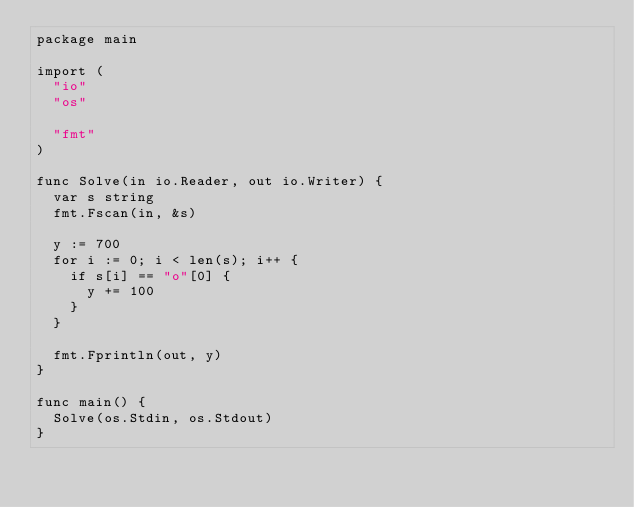Convert code to text. <code><loc_0><loc_0><loc_500><loc_500><_Go_>package main

import (
	"io"
	"os"

	"fmt"
)

func Solve(in io.Reader, out io.Writer) {
	var s string
	fmt.Fscan(in, &s)

	y := 700
	for i := 0; i < len(s); i++ {
		if s[i] == "o"[0] {
			y += 100
		}
	}

	fmt.Fprintln(out, y)
}

func main() {
	Solve(os.Stdin, os.Stdout)
}
</code> 